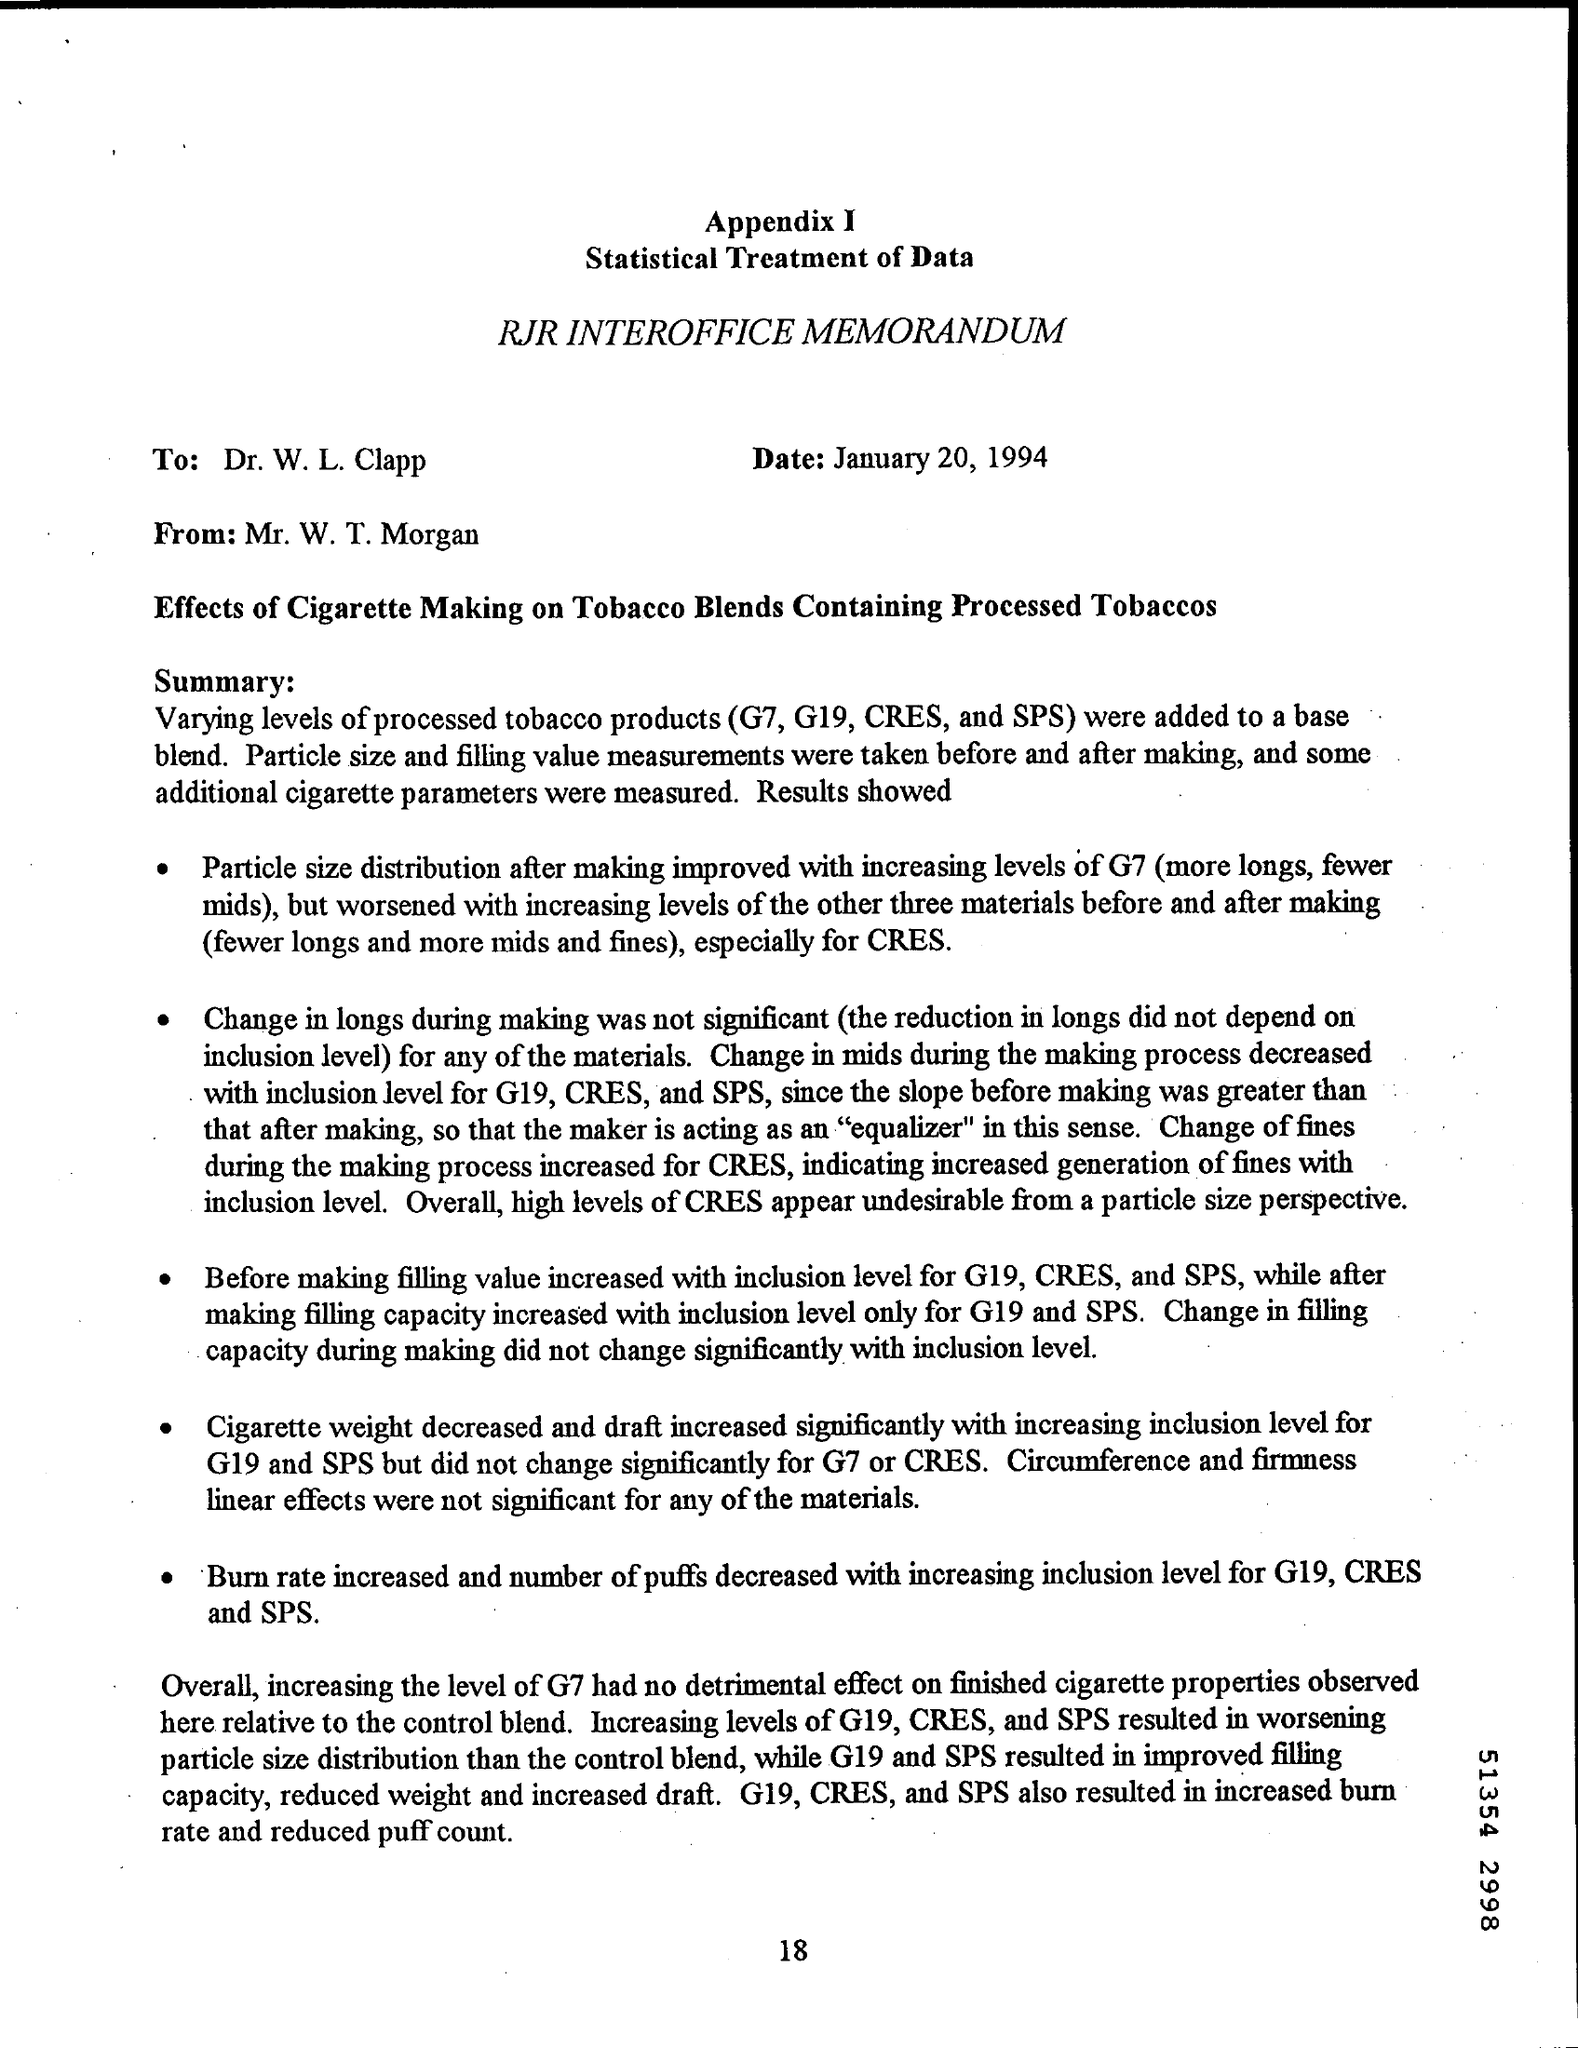Indicate a few pertinent items in this graphic. Increasing the inclusion level for G19, CRES, and SPS in a materials science experiment resulted in a higher burn rate and a decrease in the number of puffs. The base blend includes products such as G7, G19, CRES, and SPS. The recipient of the data provided by Mr. W. T. Morgan was Dr. W. L. Clapp. The effect of increased CRES levels on particle size distribution is uncertain, as it may worsen or improve the situation depending on the specific circumstances. While higher CRES levels can lead to the creation of smaller particles, they can also result in larger particles depending on the chemical reactions and other factors involved. Therefore, a comprehensive understanding of the relationship between CRES levels and particle size distribution is necessary to make informed decisions about potential environmental impacts. 